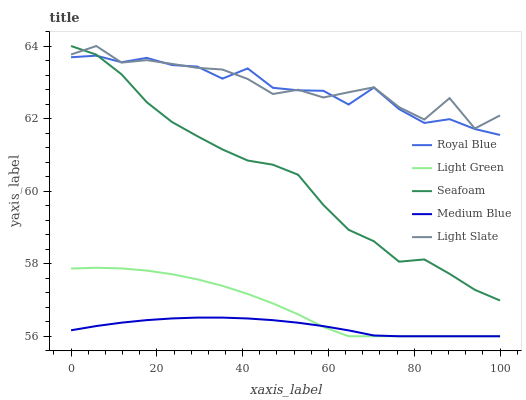Does Medium Blue have the minimum area under the curve?
Answer yes or no. Yes. Does Light Slate have the maximum area under the curve?
Answer yes or no. Yes. Does Royal Blue have the minimum area under the curve?
Answer yes or no. No. Does Royal Blue have the maximum area under the curve?
Answer yes or no. No. Is Medium Blue the smoothest?
Answer yes or no. Yes. Is Light Slate the roughest?
Answer yes or no. Yes. Is Royal Blue the smoothest?
Answer yes or no. No. Is Royal Blue the roughest?
Answer yes or no. No. Does Medium Blue have the lowest value?
Answer yes or no. Yes. Does Royal Blue have the lowest value?
Answer yes or no. No. Does Seafoam have the highest value?
Answer yes or no. Yes. Does Royal Blue have the highest value?
Answer yes or no. No. Is Light Green less than Royal Blue?
Answer yes or no. Yes. Is Light Slate greater than Medium Blue?
Answer yes or no. Yes. Does Light Slate intersect Royal Blue?
Answer yes or no. Yes. Is Light Slate less than Royal Blue?
Answer yes or no. No. Is Light Slate greater than Royal Blue?
Answer yes or no. No. Does Light Green intersect Royal Blue?
Answer yes or no. No. 